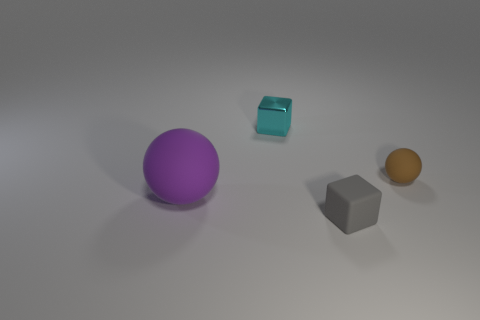Subtract all gray cubes. How many cubes are left? 1 Add 3 big yellow matte cylinders. How many objects exist? 7 Subtract 1 blocks. How many blocks are left? 1 Subtract 0 blue blocks. How many objects are left? 4 Subtract all red cubes. Subtract all cyan cylinders. How many cubes are left? 2 Subtract all matte blocks. Subtract all metallic objects. How many objects are left? 2 Add 3 balls. How many balls are left? 5 Add 2 big purple things. How many big purple things exist? 3 